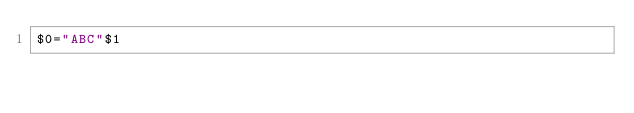<code> <loc_0><loc_0><loc_500><loc_500><_Awk_>$0="ABC"$1</code> 